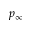Convert formula to latex. <formula><loc_0><loc_0><loc_500><loc_500>p _ { \infty }</formula> 